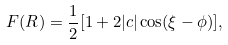Convert formula to latex. <formula><loc_0><loc_0><loc_500><loc_500>F ( R ) = \frac { 1 } { 2 } [ 1 + 2 | c | \cos ( \xi - \phi ) ] ,</formula> 